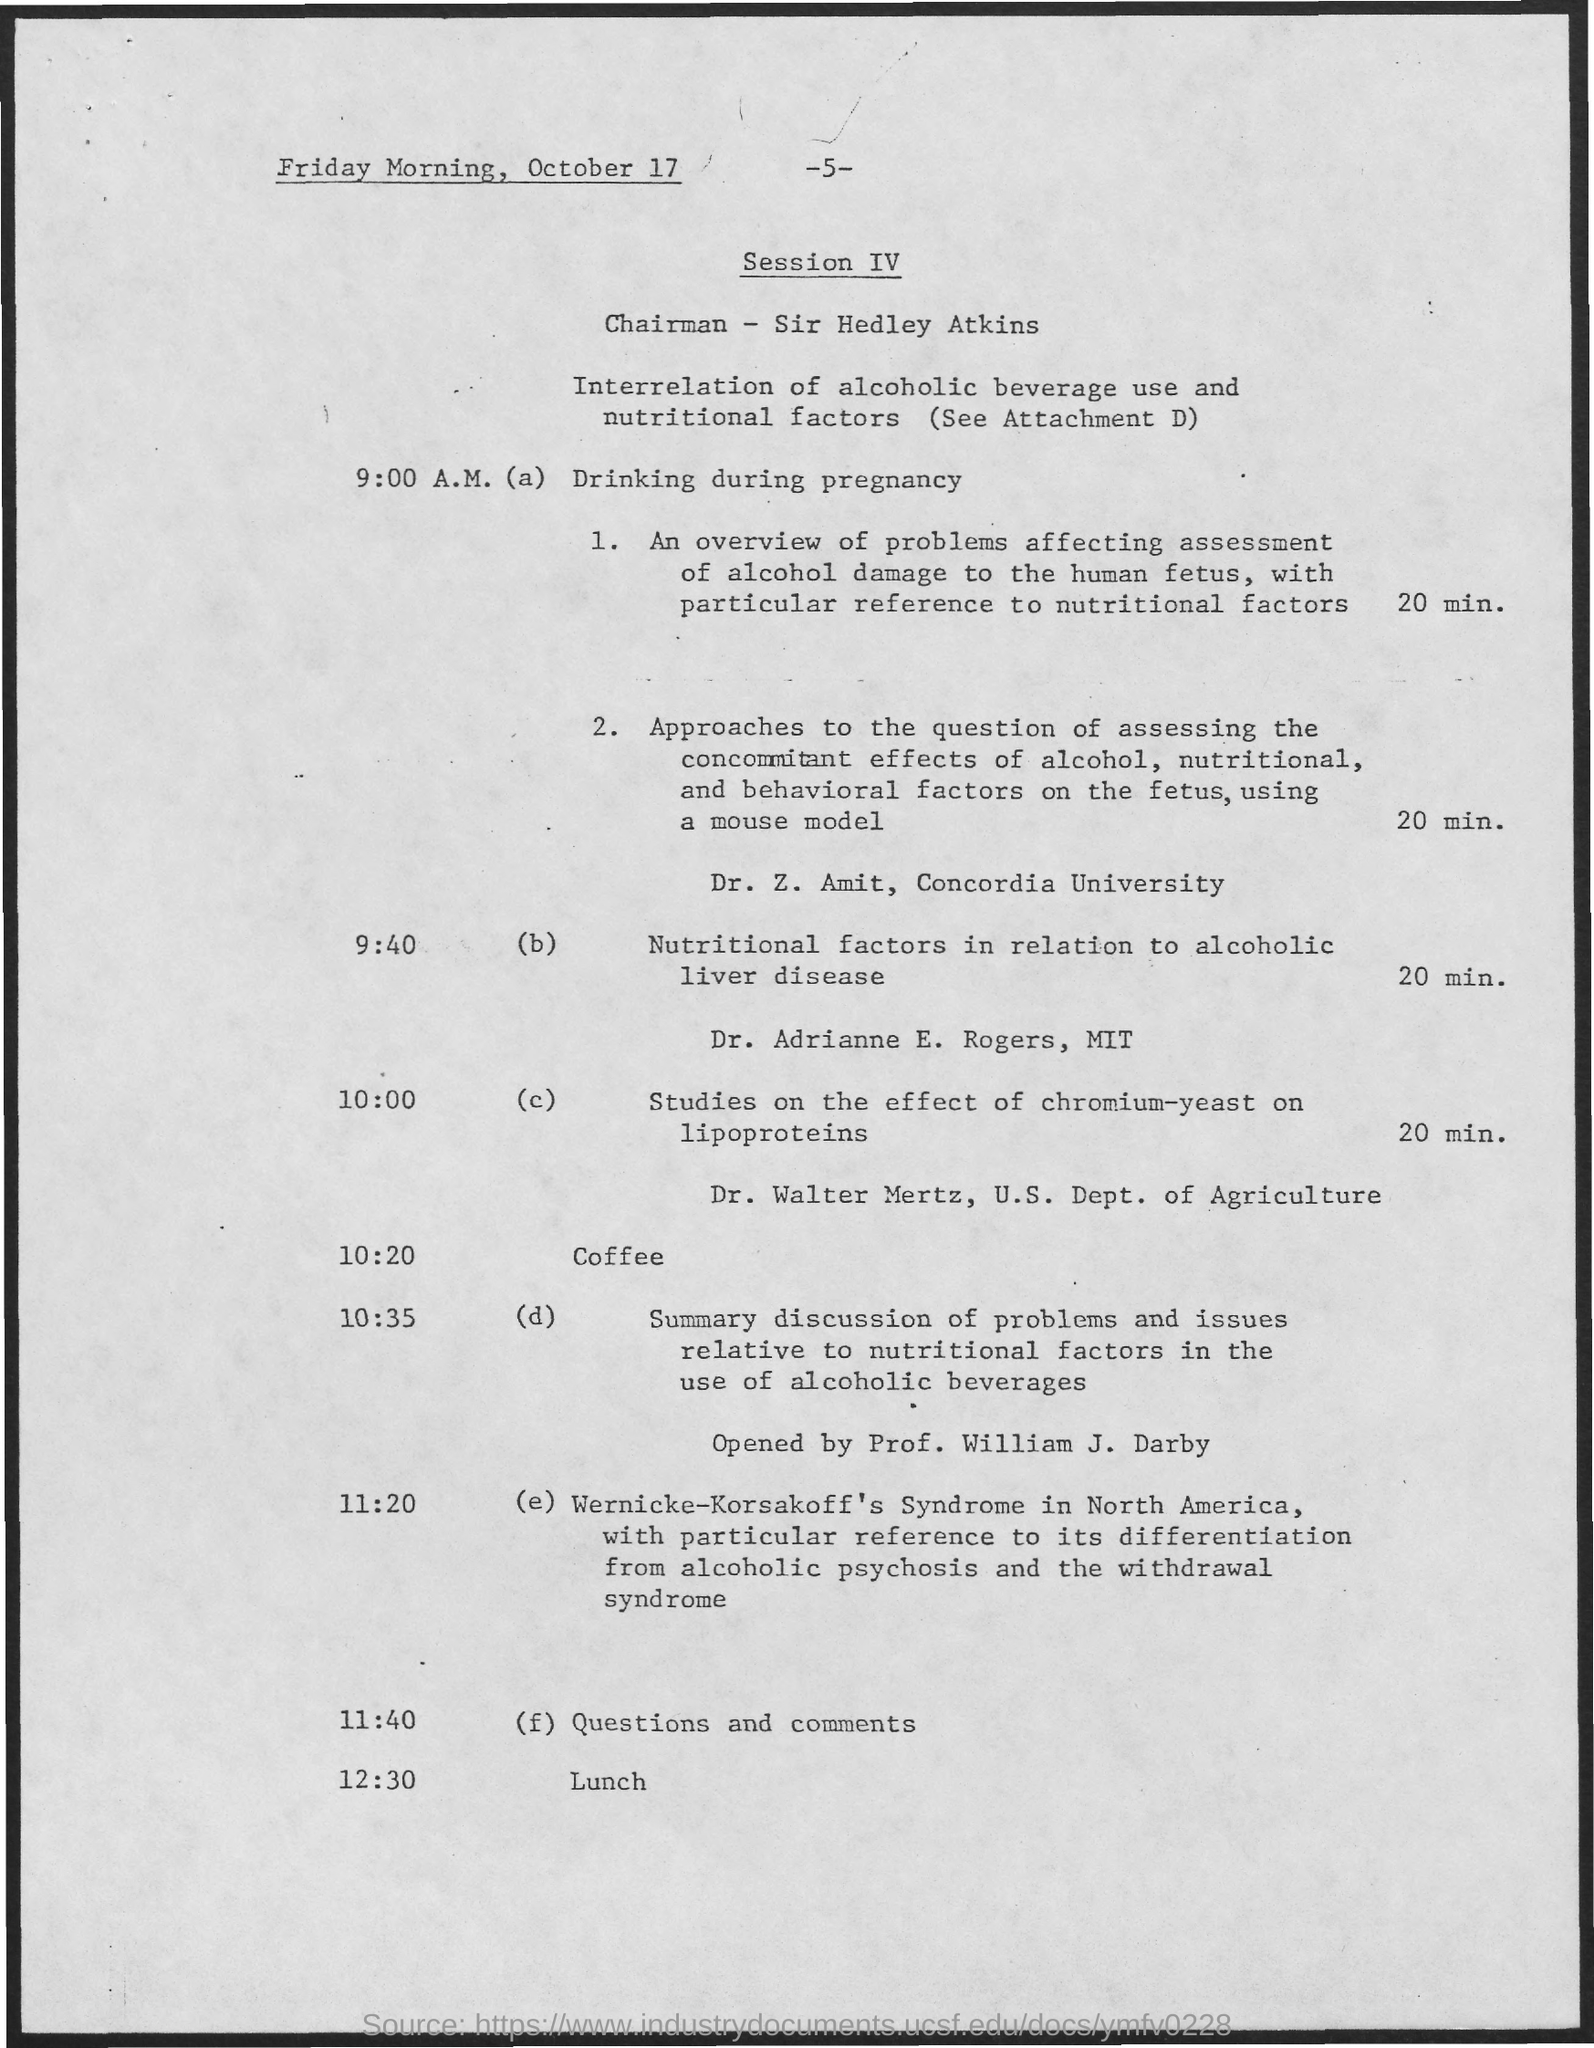Indicate a few pertinent items in this graphic. The time for questions and comments is 11:40. The day and date mentioned at the top are Friday morning, October 17. Dr. Adriamne E. Rogers will present for 20 minutes on a topic of her choice. At 9:00 A.M., the topic of discussion is drinking during pregnancy. The individual who is the chairman is Sir Hedley Atkins. 